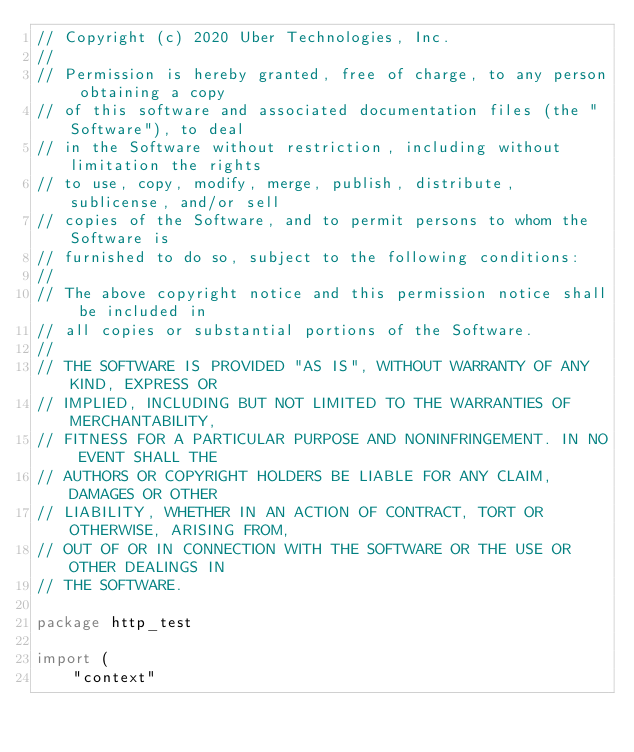<code> <loc_0><loc_0><loc_500><loc_500><_Go_>// Copyright (c) 2020 Uber Technologies, Inc.
//
// Permission is hereby granted, free of charge, to any person obtaining a copy
// of this software and associated documentation files (the "Software"), to deal
// in the Software without restriction, including without limitation the rights
// to use, copy, modify, merge, publish, distribute, sublicense, and/or sell
// copies of the Software, and to permit persons to whom the Software is
// furnished to do so, subject to the following conditions:
//
// The above copyright notice and this permission notice shall be included in
// all copies or substantial portions of the Software.
//
// THE SOFTWARE IS PROVIDED "AS IS", WITHOUT WARRANTY OF ANY KIND, EXPRESS OR
// IMPLIED, INCLUDING BUT NOT LIMITED TO THE WARRANTIES OF MERCHANTABILITY,
// FITNESS FOR A PARTICULAR PURPOSE AND NONINFRINGEMENT. IN NO EVENT SHALL THE
// AUTHORS OR COPYRIGHT HOLDERS BE LIABLE FOR ANY CLAIM, DAMAGES OR OTHER
// LIABILITY, WHETHER IN AN ACTION OF CONTRACT, TORT OR OTHERWISE, ARISING FROM,
// OUT OF OR IN CONNECTION WITH THE SOFTWARE OR THE USE OR OTHER DEALINGS IN
// THE SOFTWARE.

package http_test

import (
	"context"</code> 